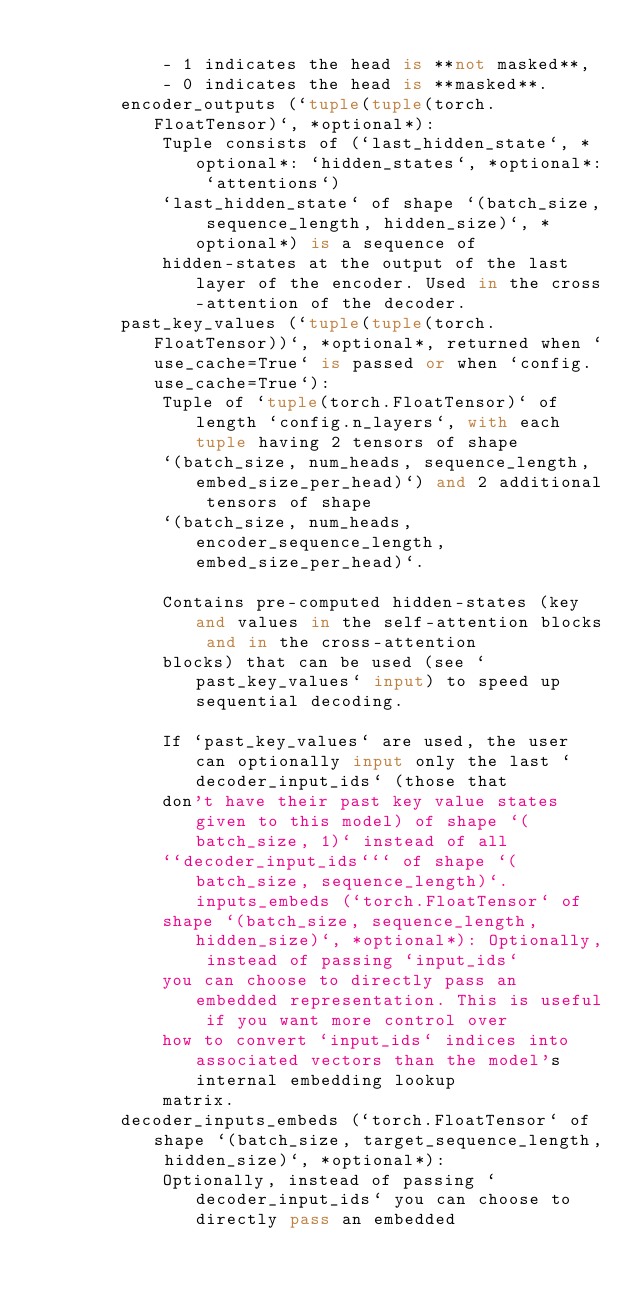<code> <loc_0><loc_0><loc_500><loc_500><_Python_>
            - 1 indicates the head is **not masked**,
            - 0 indicates the head is **masked**.
        encoder_outputs (`tuple(tuple(torch.FloatTensor)`, *optional*):
            Tuple consists of (`last_hidden_state`, *optional*: `hidden_states`, *optional*: `attentions`)
            `last_hidden_state` of shape `(batch_size, sequence_length, hidden_size)`, *optional*) is a sequence of
            hidden-states at the output of the last layer of the encoder. Used in the cross-attention of the decoder.
        past_key_values (`tuple(tuple(torch.FloatTensor))`, *optional*, returned when `use_cache=True` is passed or when `config.use_cache=True`):
            Tuple of `tuple(torch.FloatTensor)` of length `config.n_layers`, with each tuple having 2 tensors of shape
            `(batch_size, num_heads, sequence_length, embed_size_per_head)`) and 2 additional tensors of shape
            `(batch_size, num_heads, encoder_sequence_length, embed_size_per_head)`.

            Contains pre-computed hidden-states (key and values in the self-attention blocks and in the cross-attention
            blocks) that can be used (see `past_key_values` input) to speed up sequential decoding.

            If `past_key_values` are used, the user can optionally input only the last `decoder_input_ids` (those that
            don't have their past key value states given to this model) of shape `(batch_size, 1)` instead of all
            ``decoder_input_ids``` of shape `(batch_size, sequence_length)`. inputs_embeds (`torch.FloatTensor` of
            shape `(batch_size, sequence_length, hidden_size)`, *optional*): Optionally, instead of passing `input_ids`
            you can choose to directly pass an embedded representation. This is useful if you want more control over
            how to convert `input_ids` indices into associated vectors than the model's internal embedding lookup
            matrix.
        decoder_inputs_embeds (`torch.FloatTensor` of shape `(batch_size, target_sequence_length, hidden_size)`, *optional*):
            Optionally, instead of passing `decoder_input_ids` you can choose to directly pass an embedded</code> 